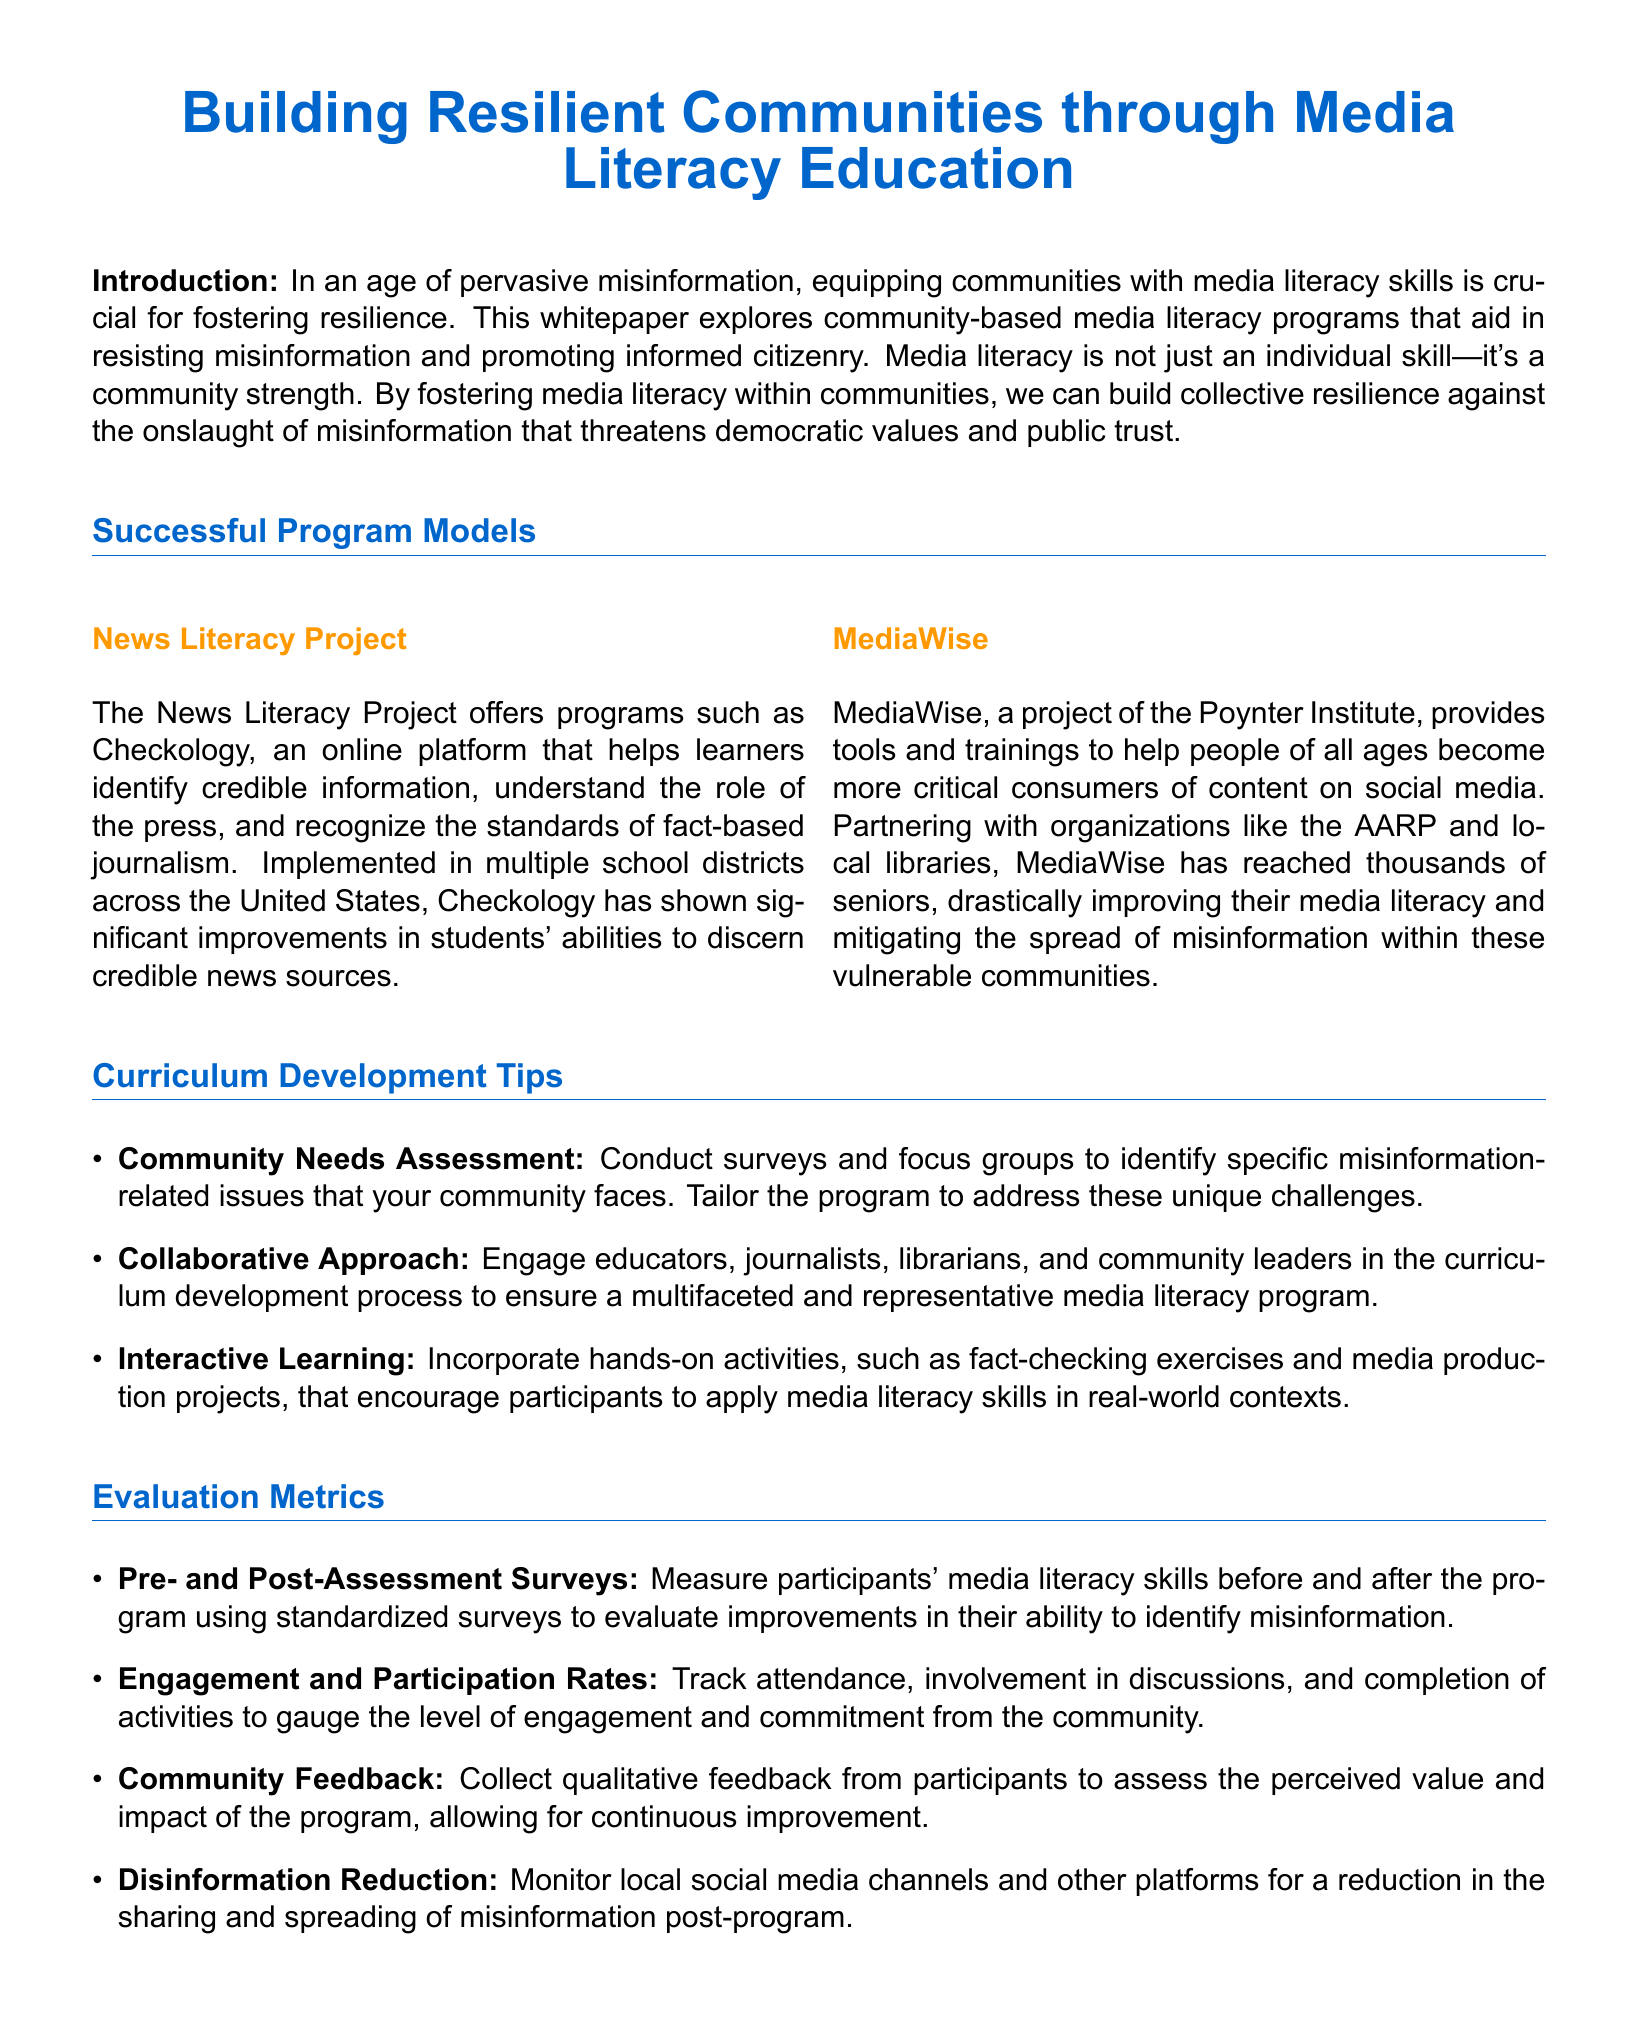What program does the News Literacy Project offer? The News Literacy Project offers Checkology, which is an online platform that helps learners identify credible information.
Answer: Checkology What organization is behind MediaWise? MediaWise is a project of the Poynter Institute.
Answer: Poynter Institute What is one method for assessing community needs in curriculum development? One method is to conduct surveys and focus groups to identify specific misinformation-related issues.
Answer: Surveys and focus groups Which demographic has MediaWise specifically reached to improve media literacy? MediaWise has reached thousands of seniors to improve their media literacy.
Answer: Seniors What is one evaluation metric used to measure engagement in the program? One evaluation metric is tracking attendance and involvement in discussions.
Answer: Attendance and involvement How can participants apply media literacy skills according to the curriculum tips? Participants can apply media literacy skills through activities such as fact-checking exercises and media production projects.
Answer: Fact-checking and media production What is the purpose of pre- and post-assessment surveys? The purpose is to measure participants' media literacy skills before and after the program.
Answer: Measure media literacy skills What impact does the program aim to have on misinformation sharing? The program aims to monitor a reduction in the sharing and spreading of misinformation.
Answer: Reduction in misinformation sharing 